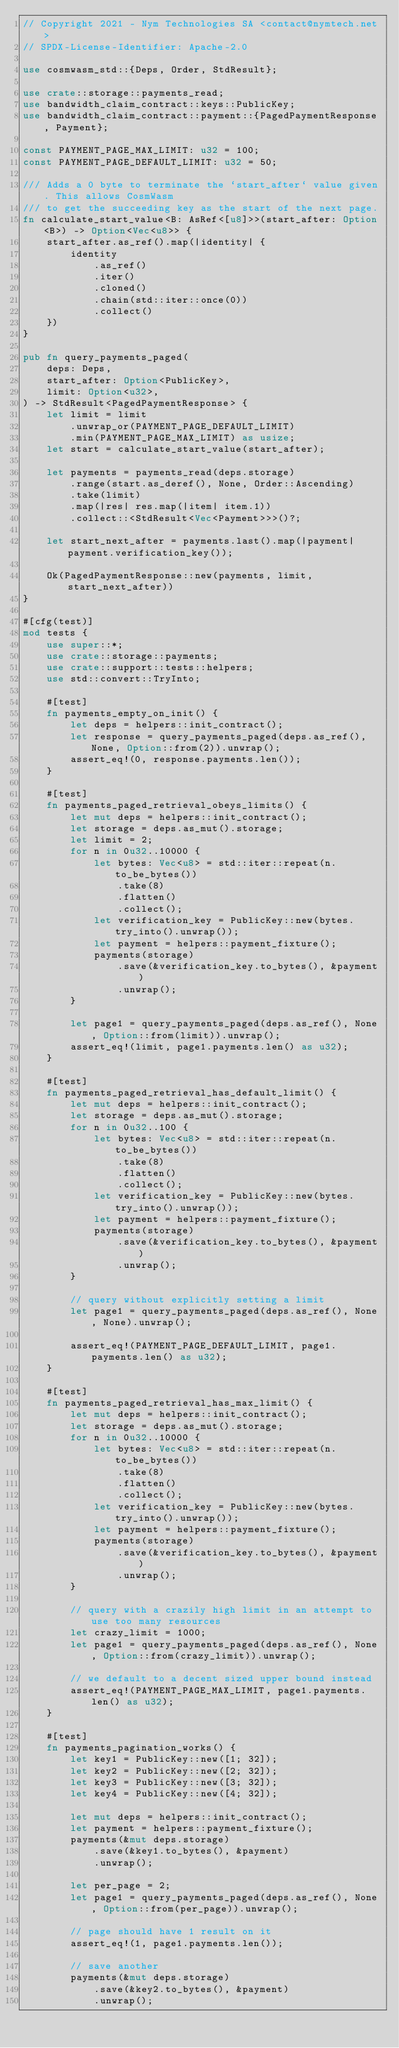Convert code to text. <code><loc_0><loc_0><loc_500><loc_500><_Rust_>// Copyright 2021 - Nym Technologies SA <contact@nymtech.net>
// SPDX-License-Identifier: Apache-2.0

use cosmwasm_std::{Deps, Order, StdResult};

use crate::storage::payments_read;
use bandwidth_claim_contract::keys::PublicKey;
use bandwidth_claim_contract::payment::{PagedPaymentResponse, Payment};

const PAYMENT_PAGE_MAX_LIMIT: u32 = 100;
const PAYMENT_PAGE_DEFAULT_LIMIT: u32 = 50;

/// Adds a 0 byte to terminate the `start_after` value given. This allows CosmWasm
/// to get the succeeding key as the start of the next page.
fn calculate_start_value<B: AsRef<[u8]>>(start_after: Option<B>) -> Option<Vec<u8>> {
    start_after.as_ref().map(|identity| {
        identity
            .as_ref()
            .iter()
            .cloned()
            .chain(std::iter::once(0))
            .collect()
    })
}

pub fn query_payments_paged(
    deps: Deps,
    start_after: Option<PublicKey>,
    limit: Option<u32>,
) -> StdResult<PagedPaymentResponse> {
    let limit = limit
        .unwrap_or(PAYMENT_PAGE_DEFAULT_LIMIT)
        .min(PAYMENT_PAGE_MAX_LIMIT) as usize;
    let start = calculate_start_value(start_after);

    let payments = payments_read(deps.storage)
        .range(start.as_deref(), None, Order::Ascending)
        .take(limit)
        .map(|res| res.map(|item| item.1))
        .collect::<StdResult<Vec<Payment>>>()?;

    let start_next_after = payments.last().map(|payment| payment.verification_key());

    Ok(PagedPaymentResponse::new(payments, limit, start_next_after))
}

#[cfg(test)]
mod tests {
    use super::*;
    use crate::storage::payments;
    use crate::support::tests::helpers;
    use std::convert::TryInto;

    #[test]
    fn payments_empty_on_init() {
        let deps = helpers::init_contract();
        let response = query_payments_paged(deps.as_ref(), None, Option::from(2)).unwrap();
        assert_eq!(0, response.payments.len());
    }

    #[test]
    fn payments_paged_retrieval_obeys_limits() {
        let mut deps = helpers::init_contract();
        let storage = deps.as_mut().storage;
        let limit = 2;
        for n in 0u32..10000 {
            let bytes: Vec<u8> = std::iter::repeat(n.to_be_bytes())
                .take(8)
                .flatten()
                .collect();
            let verification_key = PublicKey::new(bytes.try_into().unwrap());
            let payment = helpers::payment_fixture();
            payments(storage)
                .save(&verification_key.to_bytes(), &payment)
                .unwrap();
        }

        let page1 = query_payments_paged(deps.as_ref(), None, Option::from(limit)).unwrap();
        assert_eq!(limit, page1.payments.len() as u32);
    }

    #[test]
    fn payments_paged_retrieval_has_default_limit() {
        let mut deps = helpers::init_contract();
        let storage = deps.as_mut().storage;
        for n in 0u32..100 {
            let bytes: Vec<u8> = std::iter::repeat(n.to_be_bytes())
                .take(8)
                .flatten()
                .collect();
            let verification_key = PublicKey::new(bytes.try_into().unwrap());
            let payment = helpers::payment_fixture();
            payments(storage)
                .save(&verification_key.to_bytes(), &payment)
                .unwrap();
        }

        // query without explicitly setting a limit
        let page1 = query_payments_paged(deps.as_ref(), None, None).unwrap();

        assert_eq!(PAYMENT_PAGE_DEFAULT_LIMIT, page1.payments.len() as u32);
    }

    #[test]
    fn payments_paged_retrieval_has_max_limit() {
        let mut deps = helpers::init_contract();
        let storage = deps.as_mut().storage;
        for n in 0u32..10000 {
            let bytes: Vec<u8> = std::iter::repeat(n.to_be_bytes())
                .take(8)
                .flatten()
                .collect();
            let verification_key = PublicKey::new(bytes.try_into().unwrap());
            let payment = helpers::payment_fixture();
            payments(storage)
                .save(&verification_key.to_bytes(), &payment)
                .unwrap();
        }

        // query with a crazily high limit in an attempt to use too many resources
        let crazy_limit = 1000;
        let page1 = query_payments_paged(deps.as_ref(), None, Option::from(crazy_limit)).unwrap();

        // we default to a decent sized upper bound instead
        assert_eq!(PAYMENT_PAGE_MAX_LIMIT, page1.payments.len() as u32);
    }

    #[test]
    fn payments_pagination_works() {
        let key1 = PublicKey::new([1; 32]);
        let key2 = PublicKey::new([2; 32]);
        let key3 = PublicKey::new([3; 32]);
        let key4 = PublicKey::new([4; 32]);

        let mut deps = helpers::init_contract();
        let payment = helpers::payment_fixture();
        payments(&mut deps.storage)
            .save(&key1.to_bytes(), &payment)
            .unwrap();

        let per_page = 2;
        let page1 = query_payments_paged(deps.as_ref(), None, Option::from(per_page)).unwrap();

        // page should have 1 result on it
        assert_eq!(1, page1.payments.len());

        // save another
        payments(&mut deps.storage)
            .save(&key2.to_bytes(), &payment)
            .unwrap();
</code> 